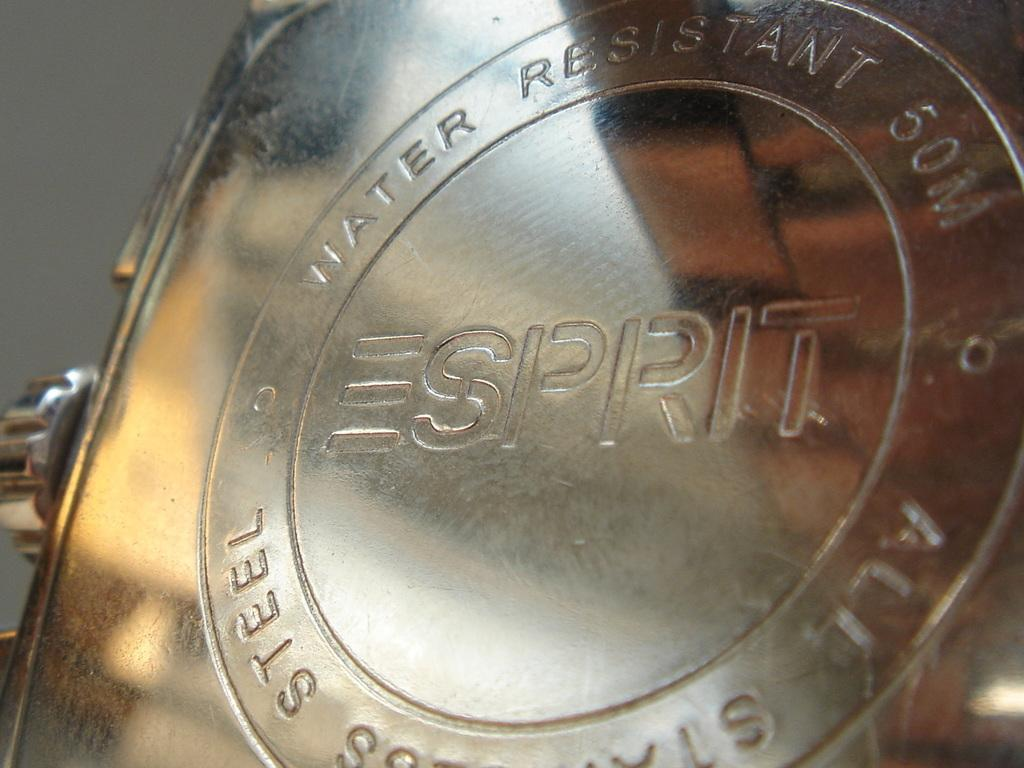<image>
Present a compact description of the photo's key features. Some metal thing that reads Water Resistant Sprit 